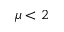<formula> <loc_0><loc_0><loc_500><loc_500>\mu < 2</formula> 